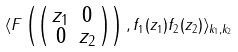<formula> <loc_0><loc_0><loc_500><loc_500>\langle F \left ( \left ( \begin{smallmatrix} z _ { 1 } & 0 \\ 0 & z _ { 2 } \end{smallmatrix} \right ) \right ) , f _ { 1 } ( z _ { 1 } ) f _ { 2 } ( z _ { 2 } ) \rangle _ { k _ { 1 } , k _ { 2 } }</formula> 